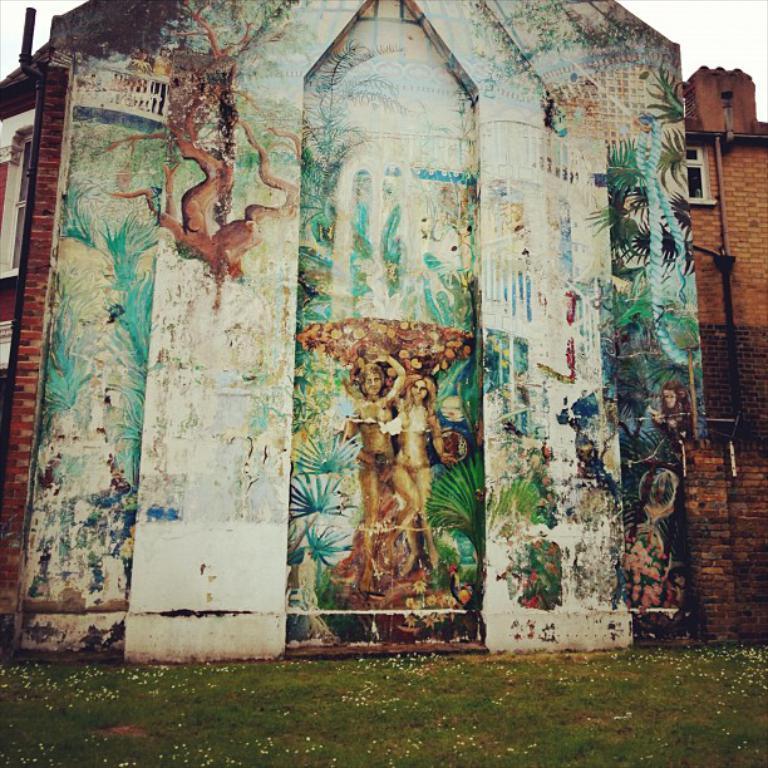Can you describe this image briefly? In this image there is a painting on the wall of a building, in front of the wall there is grass. 